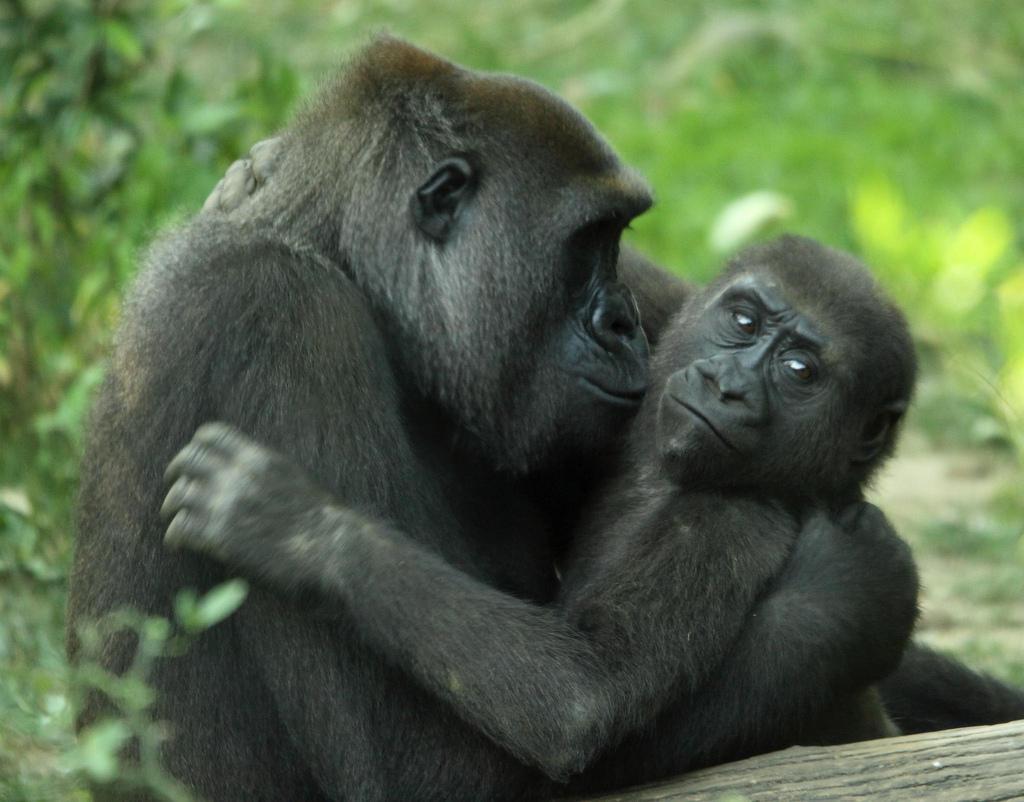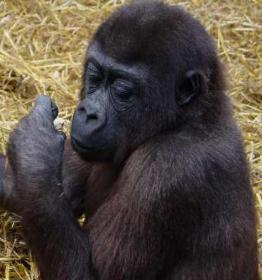The first image is the image on the left, the second image is the image on the right. Assess this claim about the two images: "There are exactly three gorillas.". Correct or not? Answer yes or no. Yes. The first image is the image on the left, the second image is the image on the right. Analyze the images presented: Is the assertion "In at least one image there are two gorilla one adult holding a single baby." valid? Answer yes or no. Yes. 